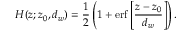Convert formula to latex. <formula><loc_0><loc_0><loc_500><loc_500>H ( z ; z _ { 0 } , d _ { w } ) = \frac { 1 } { 2 } \left ( 1 + e r f \left [ \frac { z - z _ { 0 } } { d _ { w } } \right ] \right ) .</formula> 